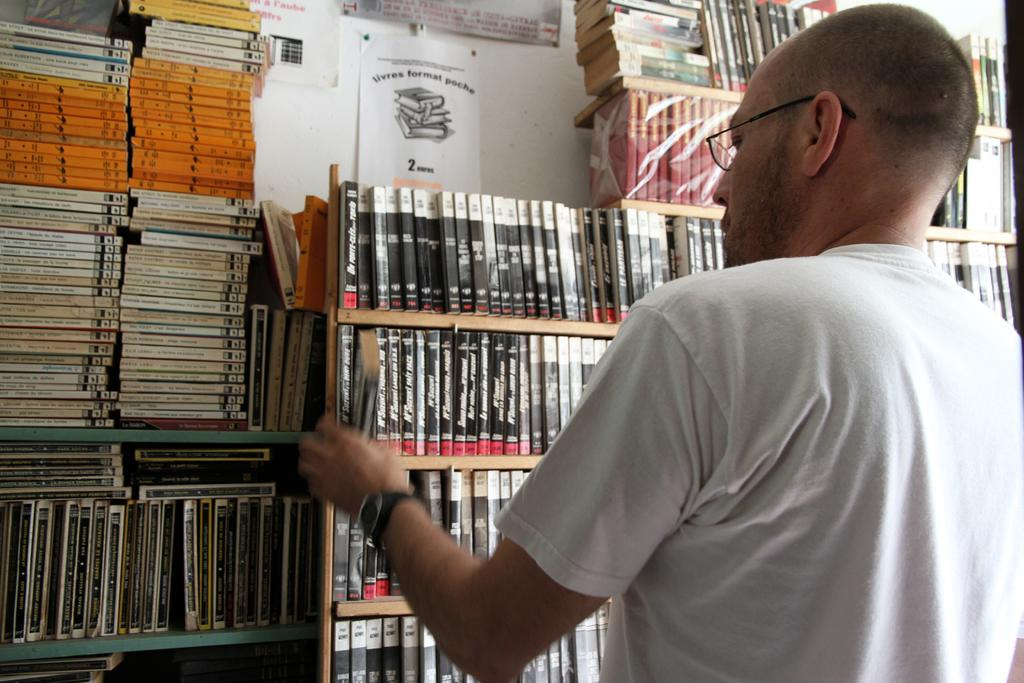<image>
Summarize the visual content of the image. A flyer hanging above book shelves has the number two on it. 